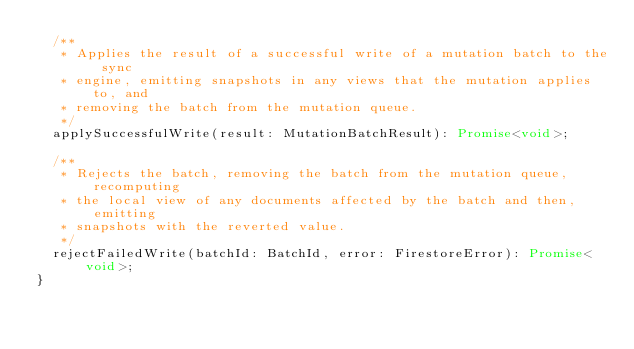Convert code to text. <code><loc_0><loc_0><loc_500><loc_500><_TypeScript_>  /**
   * Applies the result of a successful write of a mutation batch to the sync
   * engine, emitting snapshots in any views that the mutation applies to, and
   * removing the batch from the mutation queue.
   */
  applySuccessfulWrite(result: MutationBatchResult): Promise<void>;

  /**
   * Rejects the batch, removing the batch from the mutation queue, recomputing
   * the local view of any documents affected by the batch and then, emitting
   * snapshots with the reverted value.
   */
  rejectFailedWrite(batchId: BatchId, error: FirestoreError): Promise<void>;
}
</code> 